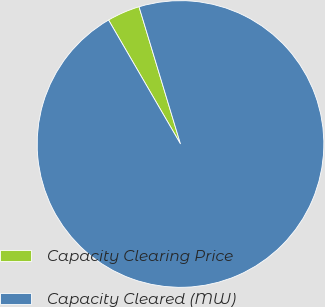Convert chart. <chart><loc_0><loc_0><loc_500><loc_500><pie_chart><fcel>Capacity Clearing Price<fcel>Capacity Cleared (MW)<nl><fcel>3.7%<fcel>96.3%<nl></chart> 